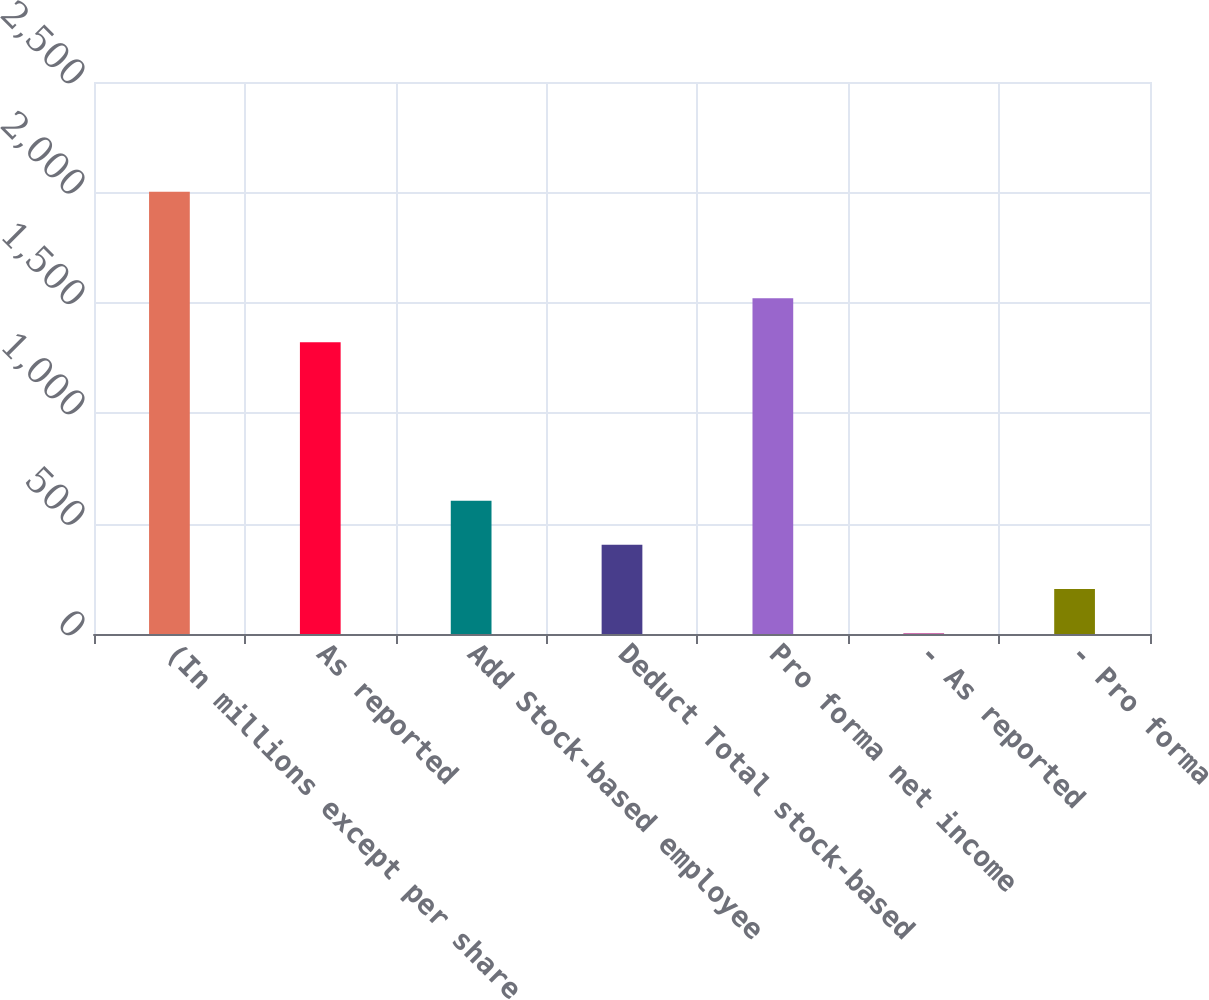Convert chart. <chart><loc_0><loc_0><loc_500><loc_500><bar_chart><fcel>(In millions except per share<fcel>As reported<fcel>Add Stock-based employee<fcel>Deduct Total stock-based<fcel>Pro forma net income<fcel>- As reported<fcel>- Pro forma<nl><fcel>2003<fcel>1321<fcel>603.87<fcel>404<fcel>1520.87<fcel>4.26<fcel>204.13<nl></chart> 